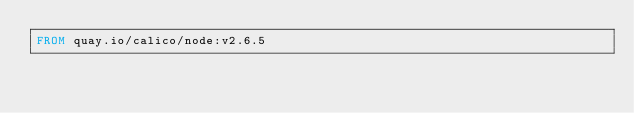<code> <loc_0><loc_0><loc_500><loc_500><_Dockerfile_>FROM quay.io/calico/node:v2.6.5
</code> 